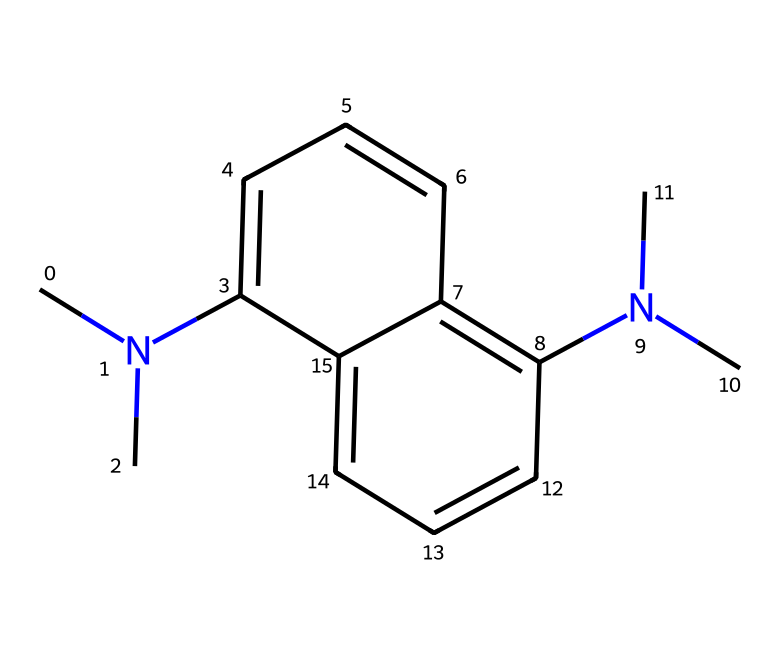What is the molecular formula of this compound? By examining the structure represented in the SMILES notation, you can identify the atoms involved. The presence of carbon (C), nitrogen (N), and hydrogen (H) implies that the molecular formula includes these elements. Counting the atoms reveals that there are 14 carbons, 2 nitrogens, and 20 hydrogens.
Answer: C14H20N2 How many rings are present in the structure? The chemical structure shows interconnected carbon atoms forming cyclic structures. By analyzing the connections in the SMILES, you can identify that there are two rings formed from the aromatic systems.
Answer: 2 How many nitrogen atoms are in the chemical structure? Looking at the SMILES, there are two N atoms present, evident from the sections of the molecule that contain “N(C)C” indicating the presence of nitrogen atoms attached to carbon groups.
Answer: 2 What kind of functional groups are present in this compound? The molecular structure has nitrogen atoms that are part of dimethylamine groups. The presence of these groups suggests basic functional properties characteristic of superbases.
Answer: dimethylamine What type of bond is primarily found in the aromatic ring of this chemical? The structure reveals that the rings are composed of alternating single and double bonds typical of aromatic compounds. By looking closely at the connections and angles between the carbon atoms, it indicates conjugated π bonds.
Answer: conjugated π bonds 